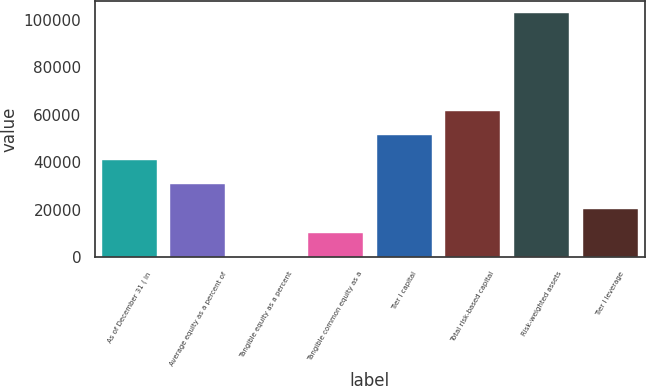Convert chart. <chart><loc_0><loc_0><loc_500><loc_500><bar_chart><fcel>As of December 31 ( in<fcel>Average equity as a percent of<fcel>Tangible equity as a percent<fcel>Tangible common equity as a<fcel>Tier I capital<fcel>Total risk-based capital<fcel>Risk-weighted assets<fcel>Tier I leverage<nl><fcel>41134<fcel>30852.5<fcel>7.95<fcel>10289.5<fcel>51415.5<fcel>61697<fcel>102823<fcel>20571<nl></chart> 